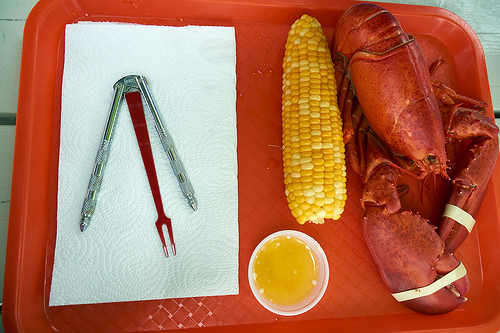<image>
Is the corn to the right of the pron? Yes. From this viewpoint, the corn is positioned to the right side relative to the pron. 